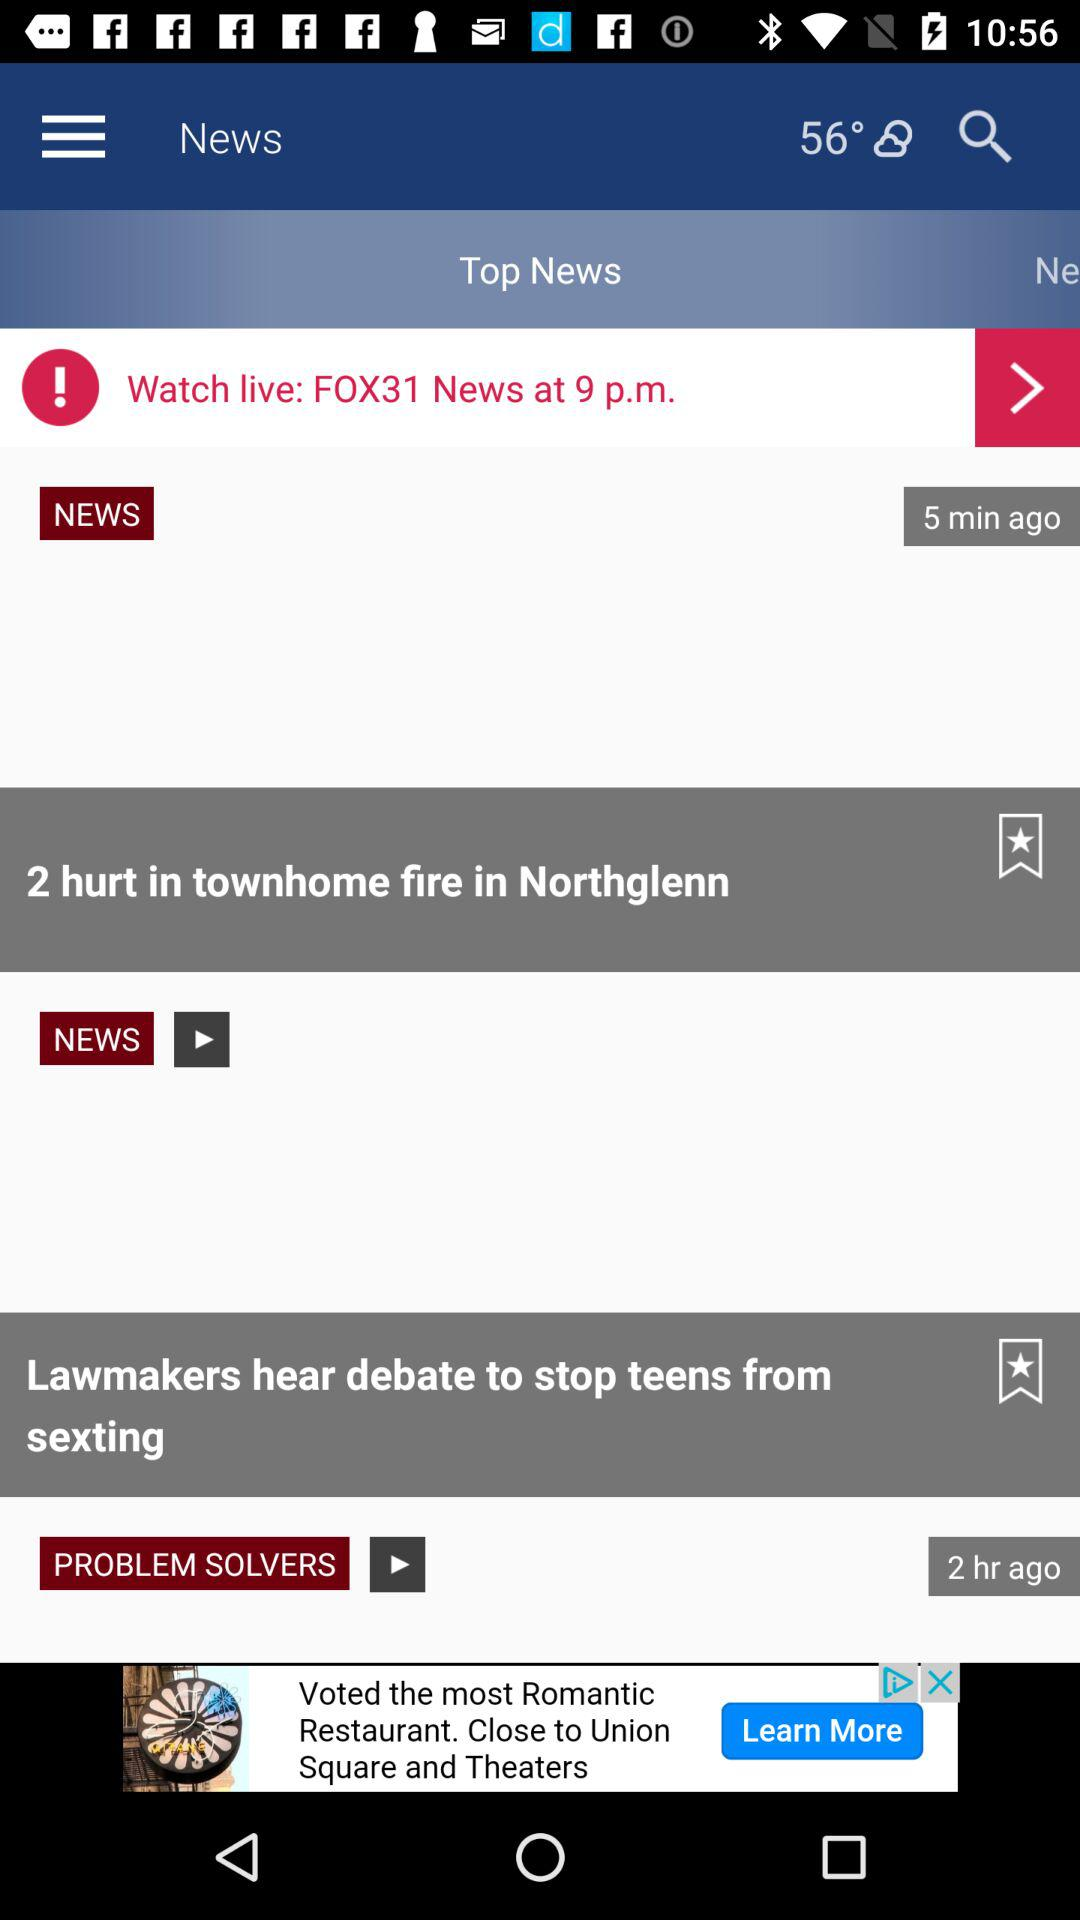How many people were injured in the Northglenn townhome fire? The number of people injured in the Northglenn townhome fire is 2. 